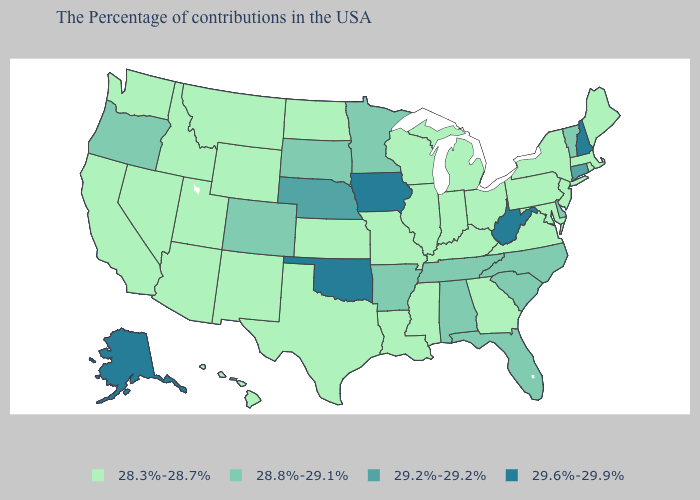What is the value of Virginia?
Keep it brief. 28.3%-28.7%. Does Pennsylvania have the lowest value in the Northeast?
Be succinct. Yes. What is the value of Missouri?
Quick response, please. 28.3%-28.7%. Which states have the highest value in the USA?
Be succinct. New Hampshire, West Virginia, Iowa, Oklahoma, Alaska. Name the states that have a value in the range 28.3%-28.7%?
Answer briefly. Maine, Massachusetts, Rhode Island, New York, New Jersey, Maryland, Pennsylvania, Virginia, Ohio, Georgia, Michigan, Kentucky, Indiana, Wisconsin, Illinois, Mississippi, Louisiana, Missouri, Kansas, Texas, North Dakota, Wyoming, New Mexico, Utah, Montana, Arizona, Idaho, Nevada, California, Washington, Hawaii. What is the lowest value in states that border New Mexico?
Short answer required. 28.3%-28.7%. What is the lowest value in the Northeast?
Keep it brief. 28.3%-28.7%. Which states have the lowest value in the USA?
Be succinct. Maine, Massachusetts, Rhode Island, New York, New Jersey, Maryland, Pennsylvania, Virginia, Ohio, Georgia, Michigan, Kentucky, Indiana, Wisconsin, Illinois, Mississippi, Louisiana, Missouri, Kansas, Texas, North Dakota, Wyoming, New Mexico, Utah, Montana, Arizona, Idaho, Nevada, California, Washington, Hawaii. Does Maine have a lower value than New York?
Quick response, please. No. Does New Mexico have the lowest value in the West?
Give a very brief answer. Yes. Among the states that border California , does Oregon have the lowest value?
Keep it brief. No. Does the map have missing data?
Quick response, please. No. What is the value of New Mexico?
Concise answer only. 28.3%-28.7%. What is the lowest value in the MidWest?
Short answer required. 28.3%-28.7%. What is the value of Virginia?
Concise answer only. 28.3%-28.7%. 